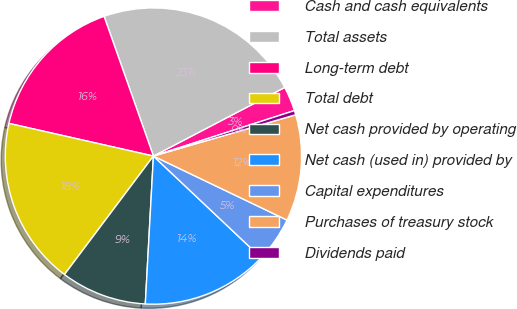<chart> <loc_0><loc_0><loc_500><loc_500><pie_chart><fcel>Cash and cash equivalents<fcel>Total assets<fcel>Long-term debt<fcel>Total debt<fcel>Net cash provided by operating<fcel>Net cash (used in) provided by<fcel>Capital expenditures<fcel>Purchases of treasury stock<fcel>Dividends paid<nl><fcel>2.7%<fcel>22.74%<fcel>16.06%<fcel>18.29%<fcel>9.38%<fcel>13.83%<fcel>4.93%<fcel>11.61%<fcel>0.47%<nl></chart> 